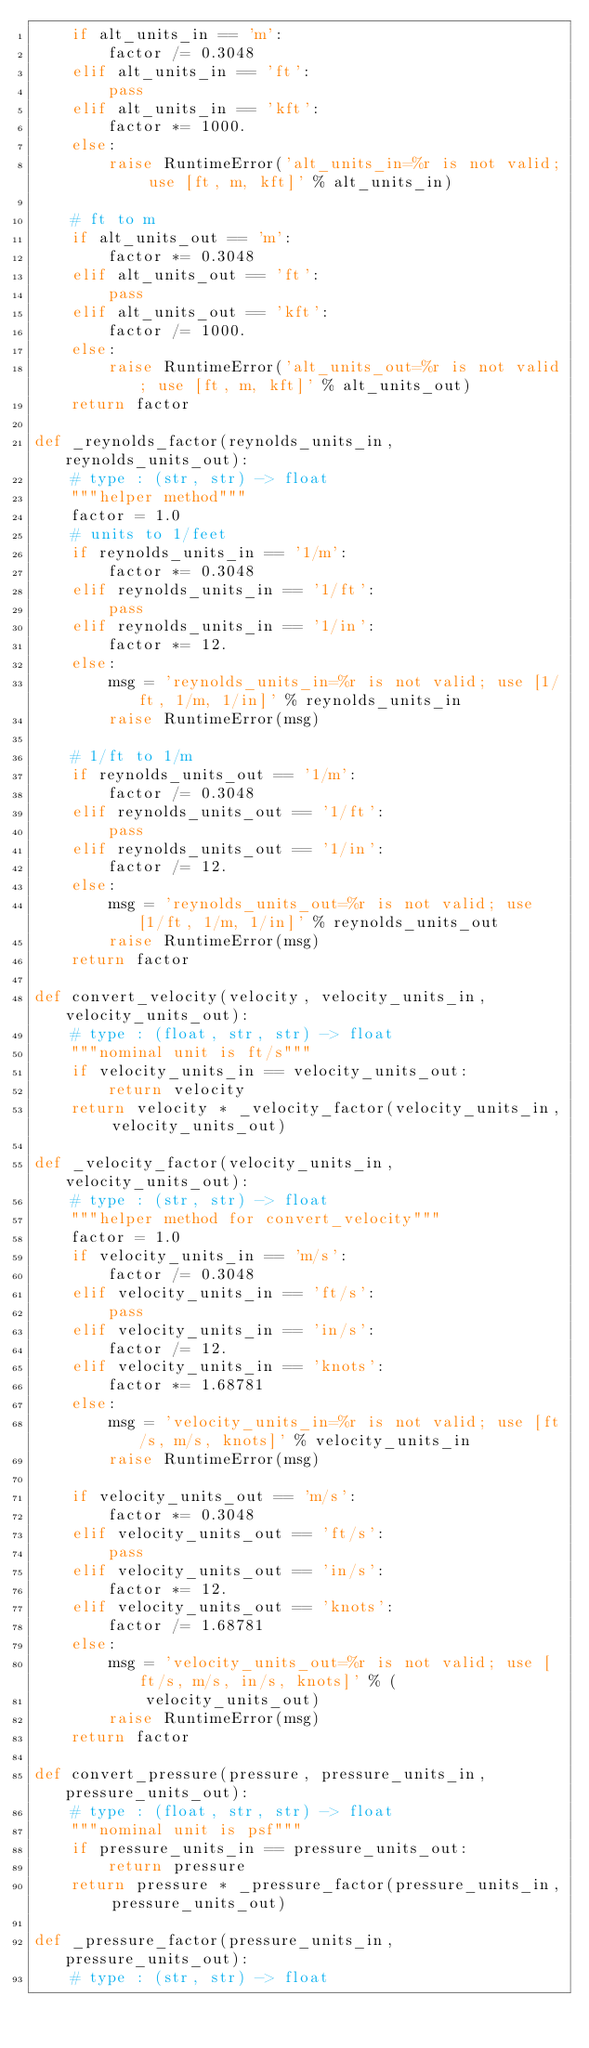Convert code to text. <code><loc_0><loc_0><loc_500><loc_500><_Python_>    if alt_units_in == 'm':
        factor /= 0.3048
    elif alt_units_in == 'ft':
        pass
    elif alt_units_in == 'kft':
        factor *= 1000.
    else:
        raise RuntimeError('alt_units_in=%r is not valid; use [ft, m, kft]' % alt_units_in)

    # ft to m
    if alt_units_out == 'm':
        factor *= 0.3048
    elif alt_units_out == 'ft':
        pass
    elif alt_units_out == 'kft':
        factor /= 1000.
    else:
        raise RuntimeError('alt_units_out=%r is not valid; use [ft, m, kft]' % alt_units_out)
    return factor

def _reynolds_factor(reynolds_units_in, reynolds_units_out):
    # type : (str, str) -> float
    """helper method"""
    factor = 1.0
    # units to 1/feet
    if reynolds_units_in == '1/m':
        factor *= 0.3048
    elif reynolds_units_in == '1/ft':
        pass
    elif reynolds_units_in == '1/in':
        factor *= 12.
    else:
        msg = 'reynolds_units_in=%r is not valid; use [1/ft, 1/m, 1/in]' % reynolds_units_in
        raise RuntimeError(msg)

    # 1/ft to 1/m
    if reynolds_units_out == '1/m':
        factor /= 0.3048
    elif reynolds_units_out == '1/ft':
        pass
    elif reynolds_units_out == '1/in':
        factor /= 12.
    else:
        msg = 'reynolds_units_out=%r is not valid; use [1/ft, 1/m, 1/in]' % reynolds_units_out
        raise RuntimeError(msg)
    return factor

def convert_velocity(velocity, velocity_units_in, velocity_units_out):
    # type : (float, str, str) -> float
    """nominal unit is ft/s"""
    if velocity_units_in == velocity_units_out:
        return velocity
    return velocity * _velocity_factor(velocity_units_in, velocity_units_out)

def _velocity_factor(velocity_units_in, velocity_units_out):
    # type : (str, str) -> float
    """helper method for convert_velocity"""
    factor = 1.0
    if velocity_units_in == 'm/s':
        factor /= 0.3048
    elif velocity_units_in == 'ft/s':
        pass
    elif velocity_units_in == 'in/s':
        factor /= 12.
    elif velocity_units_in == 'knots':
        factor *= 1.68781
    else:
        msg = 'velocity_units_in=%r is not valid; use [ft/s, m/s, knots]' % velocity_units_in
        raise RuntimeError(msg)

    if velocity_units_out == 'm/s':
        factor *= 0.3048
    elif velocity_units_out == 'ft/s':
        pass
    elif velocity_units_out == 'in/s':
        factor *= 12.
    elif velocity_units_out == 'knots':
        factor /= 1.68781
    else:
        msg = 'velocity_units_out=%r is not valid; use [ft/s, m/s, in/s, knots]' % (
            velocity_units_out)
        raise RuntimeError(msg)
    return factor

def convert_pressure(pressure, pressure_units_in, pressure_units_out):
    # type : (float, str, str) -> float
    """nominal unit is psf"""
    if pressure_units_in == pressure_units_out:
        return pressure
    return pressure * _pressure_factor(pressure_units_in, pressure_units_out)

def _pressure_factor(pressure_units_in, pressure_units_out):
    # type : (str, str) -> float</code> 